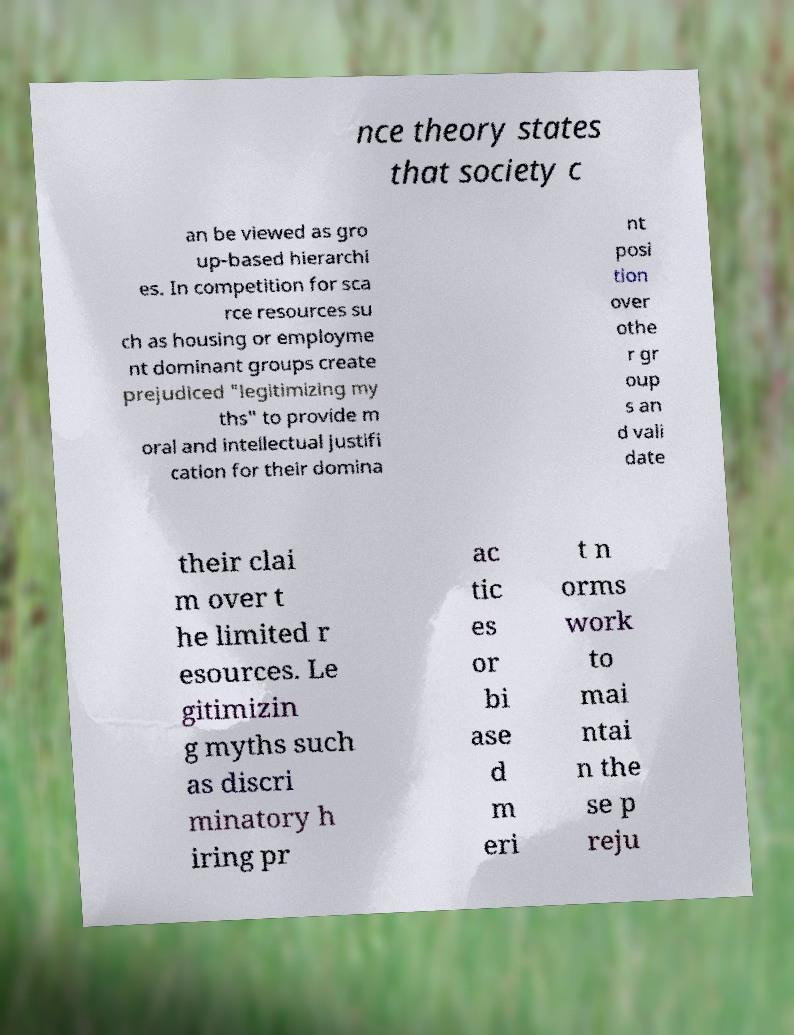What messages or text are displayed in this image? I need them in a readable, typed format. nce theory states that society c an be viewed as gro up-based hierarchi es. In competition for sca rce resources su ch as housing or employme nt dominant groups create prejudiced "legitimizing my ths" to provide m oral and intellectual justifi cation for their domina nt posi tion over othe r gr oup s an d vali date their clai m over t he limited r esources. Le gitimizin g myths such as discri minatory h iring pr ac tic es or bi ase d m eri t n orms work to mai ntai n the se p reju 